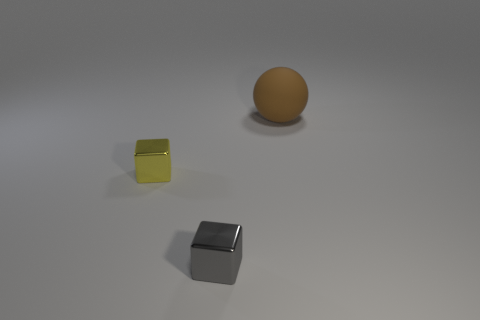Is there anything else that has the same material as the brown thing?
Offer a very short reply. No. Is the number of large brown matte things right of the tiny gray block less than the number of big gray spheres?
Your answer should be compact. No. There is a small block to the left of the gray cube; what is it made of?
Your answer should be compact. Metal. What number of other things are there of the same size as the brown matte ball?
Your answer should be compact. 0. There is a gray metallic cube; is its size the same as the shiny cube that is left of the small gray cube?
Offer a very short reply. Yes. The tiny thing in front of the small metal object that is on the left side of the block in front of the yellow metal object is what shape?
Your response must be concise. Cube. Is the number of small yellow shiny cylinders less than the number of small metallic blocks?
Keep it short and to the point. Yes. Are there any shiny blocks in front of the big brown thing?
Provide a short and direct response. Yes. The object that is on the right side of the small yellow metallic cube and behind the gray block has what shape?
Keep it short and to the point. Sphere. Are there any other metallic things that have the same shape as the small gray thing?
Offer a terse response. Yes. 